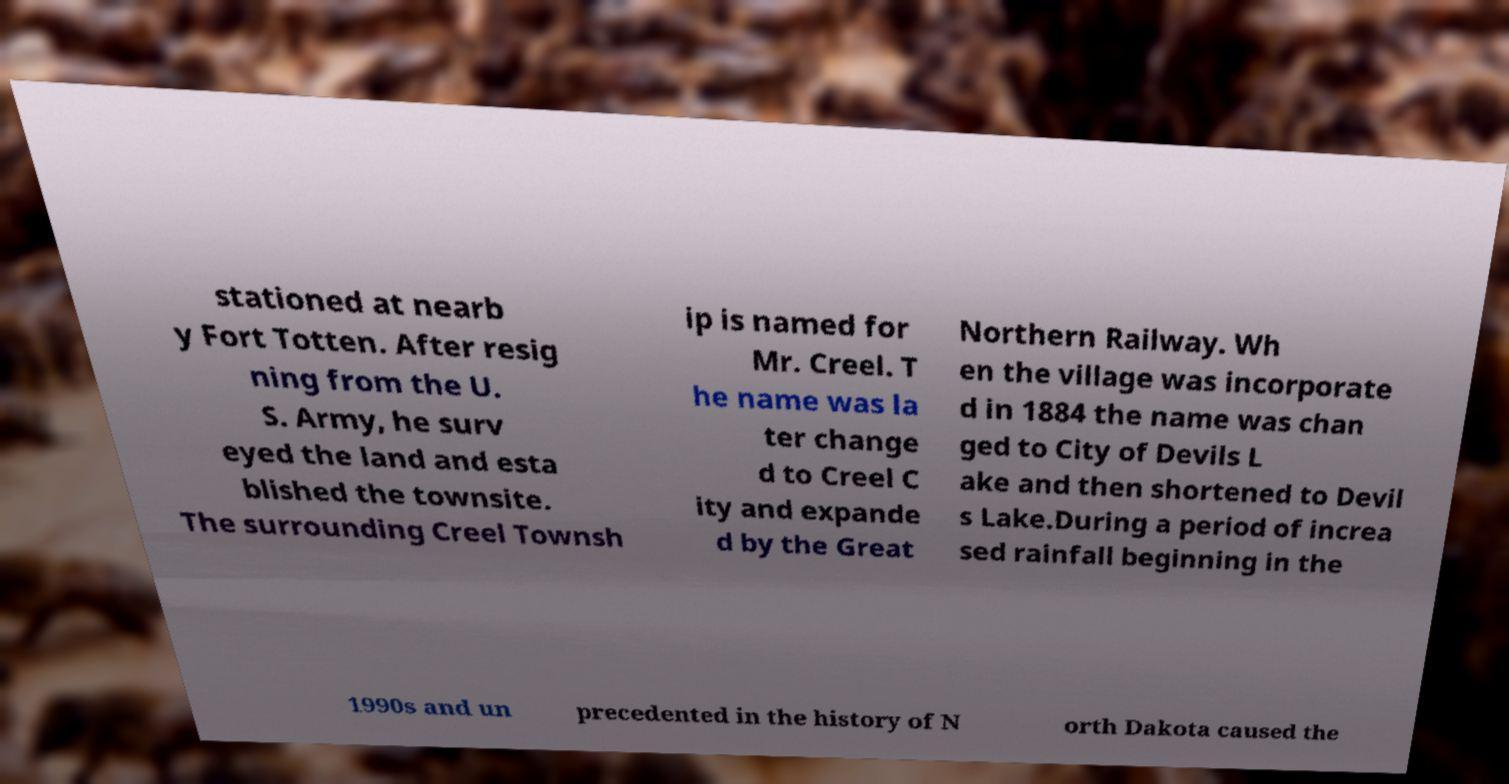What messages or text are displayed in this image? I need them in a readable, typed format. stationed at nearb y Fort Totten. After resig ning from the U. S. Army, he surv eyed the land and esta blished the townsite. The surrounding Creel Townsh ip is named for Mr. Creel. T he name was la ter change d to Creel C ity and expande d by the Great Northern Railway. Wh en the village was incorporate d in 1884 the name was chan ged to City of Devils L ake and then shortened to Devil s Lake.During a period of increa sed rainfall beginning in the 1990s and un precedented in the history of N orth Dakota caused the 